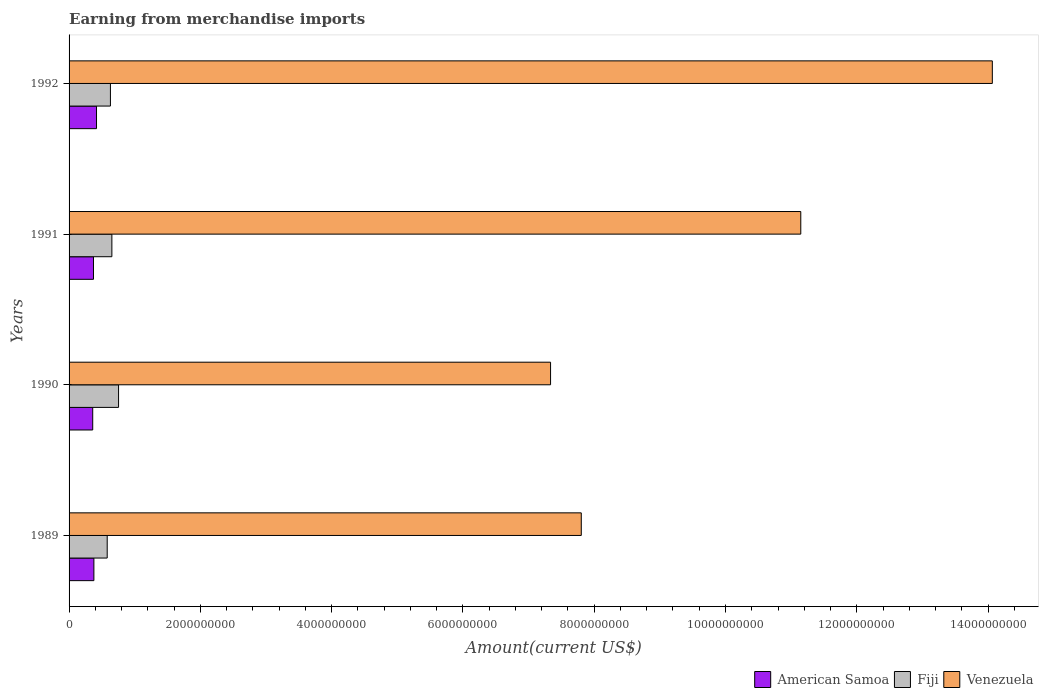How many groups of bars are there?
Make the answer very short. 4. Are the number of bars on each tick of the Y-axis equal?
Your response must be concise. Yes. How many bars are there on the 2nd tick from the top?
Ensure brevity in your answer.  3. How many bars are there on the 4th tick from the bottom?
Make the answer very short. 3. What is the amount earned from merchandise imports in Venezuela in 1992?
Provide a short and direct response. 1.41e+1. Across all years, what is the maximum amount earned from merchandise imports in Venezuela?
Your response must be concise. 1.41e+1. Across all years, what is the minimum amount earned from merchandise imports in Fiji?
Your response must be concise. 5.81e+08. In which year was the amount earned from merchandise imports in American Samoa minimum?
Give a very brief answer. 1990. What is the total amount earned from merchandise imports in Venezuela in the graph?
Offer a terse response. 4.04e+1. What is the difference between the amount earned from merchandise imports in American Samoa in 1991 and that in 1992?
Ensure brevity in your answer.  -4.61e+07. What is the difference between the amount earned from merchandise imports in Venezuela in 1990 and the amount earned from merchandise imports in American Samoa in 1991?
Make the answer very short. 6.96e+09. What is the average amount earned from merchandise imports in American Samoa per year?
Your response must be concise. 3.82e+08. In the year 1991, what is the difference between the amount earned from merchandise imports in Venezuela and amount earned from merchandise imports in American Samoa?
Keep it short and to the point. 1.08e+1. What is the ratio of the amount earned from merchandise imports in Fiji in 1990 to that in 1991?
Give a very brief answer. 1.16. Is the amount earned from merchandise imports in Venezuela in 1989 less than that in 1992?
Make the answer very short. Yes. Is the difference between the amount earned from merchandise imports in Venezuela in 1989 and 1991 greater than the difference between the amount earned from merchandise imports in American Samoa in 1989 and 1991?
Make the answer very short. No. What is the difference between the highest and the second highest amount earned from merchandise imports in Venezuela?
Provide a short and direct response. 2.92e+09. What is the difference between the highest and the lowest amount earned from merchandise imports in Venezuela?
Offer a terse response. 6.73e+09. Is the sum of the amount earned from merchandise imports in Venezuela in 1991 and 1992 greater than the maximum amount earned from merchandise imports in Fiji across all years?
Make the answer very short. Yes. What does the 2nd bar from the top in 1991 represents?
Offer a terse response. Fiji. What does the 1st bar from the bottom in 1990 represents?
Offer a very short reply. American Samoa. Is it the case that in every year, the sum of the amount earned from merchandise imports in Fiji and amount earned from merchandise imports in American Samoa is greater than the amount earned from merchandise imports in Venezuela?
Offer a terse response. No. Are all the bars in the graph horizontal?
Provide a succinct answer. Yes. What is the difference between two consecutive major ticks on the X-axis?
Your answer should be compact. 2.00e+09. Does the graph contain any zero values?
Make the answer very short. No. Does the graph contain grids?
Ensure brevity in your answer.  No. Where does the legend appear in the graph?
Provide a short and direct response. Bottom right. How many legend labels are there?
Provide a succinct answer. 3. How are the legend labels stacked?
Your response must be concise. Horizontal. What is the title of the graph?
Make the answer very short. Earning from merchandise imports. What is the label or title of the X-axis?
Your answer should be very brief. Amount(current US$). What is the Amount(current US$) of American Samoa in 1989?
Give a very brief answer. 3.78e+08. What is the Amount(current US$) of Fiji in 1989?
Keep it short and to the point. 5.81e+08. What is the Amount(current US$) of Venezuela in 1989?
Provide a short and direct response. 7.80e+09. What is the Amount(current US$) of American Samoa in 1990?
Give a very brief answer. 3.60e+08. What is the Amount(current US$) of Fiji in 1990?
Your answer should be very brief. 7.54e+08. What is the Amount(current US$) of Venezuela in 1990?
Offer a terse response. 7.34e+09. What is the Amount(current US$) of American Samoa in 1991?
Offer a very short reply. 3.72e+08. What is the Amount(current US$) of Fiji in 1991?
Your response must be concise. 6.52e+08. What is the Amount(current US$) in Venezuela in 1991?
Your answer should be compact. 1.11e+1. What is the Amount(current US$) in American Samoa in 1992?
Provide a succinct answer. 4.18e+08. What is the Amount(current US$) of Fiji in 1992?
Offer a terse response. 6.30e+08. What is the Amount(current US$) of Venezuela in 1992?
Make the answer very short. 1.41e+1. Across all years, what is the maximum Amount(current US$) in American Samoa?
Provide a short and direct response. 4.18e+08. Across all years, what is the maximum Amount(current US$) in Fiji?
Offer a terse response. 7.54e+08. Across all years, what is the maximum Amount(current US$) in Venezuela?
Keep it short and to the point. 1.41e+1. Across all years, what is the minimum Amount(current US$) in American Samoa?
Provide a succinct answer. 3.60e+08. Across all years, what is the minimum Amount(current US$) in Fiji?
Offer a very short reply. 5.81e+08. Across all years, what is the minimum Amount(current US$) in Venezuela?
Your response must be concise. 7.34e+09. What is the total Amount(current US$) of American Samoa in the graph?
Offer a very short reply. 1.53e+09. What is the total Amount(current US$) of Fiji in the graph?
Provide a succinct answer. 2.62e+09. What is the total Amount(current US$) of Venezuela in the graph?
Ensure brevity in your answer.  4.04e+1. What is the difference between the Amount(current US$) of American Samoa in 1989 and that in 1990?
Offer a very short reply. 1.77e+07. What is the difference between the Amount(current US$) of Fiji in 1989 and that in 1990?
Offer a terse response. -1.73e+08. What is the difference between the Amount(current US$) of Venezuela in 1989 and that in 1990?
Your answer should be compact. 4.68e+08. What is the difference between the Amount(current US$) in American Samoa in 1989 and that in 1991?
Provide a succinct answer. 6.10e+06. What is the difference between the Amount(current US$) of Fiji in 1989 and that in 1991?
Give a very brief answer. -7.10e+07. What is the difference between the Amount(current US$) in Venezuela in 1989 and that in 1991?
Your answer should be very brief. -3.34e+09. What is the difference between the Amount(current US$) of American Samoa in 1989 and that in 1992?
Your answer should be very brief. -4.00e+07. What is the difference between the Amount(current US$) of Fiji in 1989 and that in 1992?
Provide a succinct answer. -4.90e+07. What is the difference between the Amount(current US$) in Venezuela in 1989 and that in 1992?
Provide a succinct answer. -6.26e+09. What is the difference between the Amount(current US$) in American Samoa in 1990 and that in 1991?
Offer a very short reply. -1.16e+07. What is the difference between the Amount(current US$) of Fiji in 1990 and that in 1991?
Keep it short and to the point. 1.02e+08. What is the difference between the Amount(current US$) of Venezuela in 1990 and that in 1991?
Provide a short and direct response. -3.81e+09. What is the difference between the Amount(current US$) of American Samoa in 1990 and that in 1992?
Your answer should be very brief. -5.77e+07. What is the difference between the Amount(current US$) of Fiji in 1990 and that in 1992?
Ensure brevity in your answer.  1.24e+08. What is the difference between the Amount(current US$) of Venezuela in 1990 and that in 1992?
Your answer should be compact. -6.73e+09. What is the difference between the Amount(current US$) of American Samoa in 1991 and that in 1992?
Provide a short and direct response. -4.61e+07. What is the difference between the Amount(current US$) in Fiji in 1991 and that in 1992?
Your answer should be compact. 2.20e+07. What is the difference between the Amount(current US$) in Venezuela in 1991 and that in 1992?
Provide a short and direct response. -2.92e+09. What is the difference between the Amount(current US$) of American Samoa in 1989 and the Amount(current US$) of Fiji in 1990?
Offer a very short reply. -3.76e+08. What is the difference between the Amount(current US$) in American Samoa in 1989 and the Amount(current US$) in Venezuela in 1990?
Your response must be concise. -6.96e+09. What is the difference between the Amount(current US$) of Fiji in 1989 and the Amount(current US$) of Venezuela in 1990?
Provide a succinct answer. -6.75e+09. What is the difference between the Amount(current US$) of American Samoa in 1989 and the Amount(current US$) of Fiji in 1991?
Provide a short and direct response. -2.74e+08. What is the difference between the Amount(current US$) of American Samoa in 1989 and the Amount(current US$) of Venezuela in 1991?
Give a very brief answer. -1.08e+1. What is the difference between the Amount(current US$) in Fiji in 1989 and the Amount(current US$) in Venezuela in 1991?
Give a very brief answer. -1.06e+1. What is the difference between the Amount(current US$) in American Samoa in 1989 and the Amount(current US$) in Fiji in 1992?
Give a very brief answer. -2.52e+08. What is the difference between the Amount(current US$) in American Samoa in 1989 and the Amount(current US$) in Venezuela in 1992?
Make the answer very short. -1.37e+1. What is the difference between the Amount(current US$) in Fiji in 1989 and the Amount(current US$) in Venezuela in 1992?
Ensure brevity in your answer.  -1.35e+1. What is the difference between the Amount(current US$) in American Samoa in 1990 and the Amount(current US$) in Fiji in 1991?
Ensure brevity in your answer.  -2.92e+08. What is the difference between the Amount(current US$) in American Samoa in 1990 and the Amount(current US$) in Venezuela in 1991?
Your answer should be very brief. -1.08e+1. What is the difference between the Amount(current US$) of Fiji in 1990 and the Amount(current US$) of Venezuela in 1991?
Your answer should be very brief. -1.04e+1. What is the difference between the Amount(current US$) of American Samoa in 1990 and the Amount(current US$) of Fiji in 1992?
Your answer should be compact. -2.70e+08. What is the difference between the Amount(current US$) of American Samoa in 1990 and the Amount(current US$) of Venezuela in 1992?
Make the answer very short. -1.37e+1. What is the difference between the Amount(current US$) of Fiji in 1990 and the Amount(current US$) of Venezuela in 1992?
Your response must be concise. -1.33e+1. What is the difference between the Amount(current US$) in American Samoa in 1991 and the Amount(current US$) in Fiji in 1992?
Give a very brief answer. -2.58e+08. What is the difference between the Amount(current US$) in American Samoa in 1991 and the Amount(current US$) in Venezuela in 1992?
Provide a short and direct response. -1.37e+1. What is the difference between the Amount(current US$) in Fiji in 1991 and the Amount(current US$) in Venezuela in 1992?
Ensure brevity in your answer.  -1.34e+1. What is the average Amount(current US$) in American Samoa per year?
Offer a terse response. 3.82e+08. What is the average Amount(current US$) of Fiji per year?
Keep it short and to the point. 6.54e+08. What is the average Amount(current US$) in Venezuela per year?
Make the answer very short. 1.01e+1. In the year 1989, what is the difference between the Amount(current US$) of American Samoa and Amount(current US$) of Fiji?
Offer a very short reply. -2.03e+08. In the year 1989, what is the difference between the Amount(current US$) of American Samoa and Amount(current US$) of Venezuela?
Make the answer very short. -7.42e+09. In the year 1989, what is the difference between the Amount(current US$) of Fiji and Amount(current US$) of Venezuela?
Offer a very short reply. -7.22e+09. In the year 1990, what is the difference between the Amount(current US$) in American Samoa and Amount(current US$) in Fiji?
Keep it short and to the point. -3.94e+08. In the year 1990, what is the difference between the Amount(current US$) of American Samoa and Amount(current US$) of Venezuela?
Your answer should be compact. -6.97e+09. In the year 1990, what is the difference between the Amount(current US$) of Fiji and Amount(current US$) of Venezuela?
Your answer should be compact. -6.58e+09. In the year 1991, what is the difference between the Amount(current US$) of American Samoa and Amount(current US$) of Fiji?
Give a very brief answer. -2.80e+08. In the year 1991, what is the difference between the Amount(current US$) of American Samoa and Amount(current US$) of Venezuela?
Keep it short and to the point. -1.08e+1. In the year 1991, what is the difference between the Amount(current US$) in Fiji and Amount(current US$) in Venezuela?
Offer a very short reply. -1.05e+1. In the year 1992, what is the difference between the Amount(current US$) in American Samoa and Amount(current US$) in Fiji?
Provide a short and direct response. -2.12e+08. In the year 1992, what is the difference between the Amount(current US$) in American Samoa and Amount(current US$) in Venezuela?
Your answer should be compact. -1.36e+1. In the year 1992, what is the difference between the Amount(current US$) of Fiji and Amount(current US$) of Venezuela?
Provide a short and direct response. -1.34e+1. What is the ratio of the Amount(current US$) of American Samoa in 1989 to that in 1990?
Offer a terse response. 1.05. What is the ratio of the Amount(current US$) in Fiji in 1989 to that in 1990?
Your answer should be very brief. 0.77. What is the ratio of the Amount(current US$) of Venezuela in 1989 to that in 1990?
Provide a short and direct response. 1.06. What is the ratio of the Amount(current US$) in American Samoa in 1989 to that in 1991?
Your answer should be very brief. 1.02. What is the ratio of the Amount(current US$) in Fiji in 1989 to that in 1991?
Ensure brevity in your answer.  0.89. What is the ratio of the Amount(current US$) in American Samoa in 1989 to that in 1992?
Offer a terse response. 0.9. What is the ratio of the Amount(current US$) of Fiji in 1989 to that in 1992?
Offer a terse response. 0.92. What is the ratio of the Amount(current US$) in Venezuela in 1989 to that in 1992?
Your answer should be compact. 0.55. What is the ratio of the Amount(current US$) in American Samoa in 1990 to that in 1991?
Keep it short and to the point. 0.97. What is the ratio of the Amount(current US$) of Fiji in 1990 to that in 1991?
Your response must be concise. 1.16. What is the ratio of the Amount(current US$) of Venezuela in 1990 to that in 1991?
Offer a very short reply. 0.66. What is the ratio of the Amount(current US$) of American Samoa in 1990 to that in 1992?
Ensure brevity in your answer.  0.86. What is the ratio of the Amount(current US$) of Fiji in 1990 to that in 1992?
Keep it short and to the point. 1.2. What is the ratio of the Amount(current US$) in Venezuela in 1990 to that in 1992?
Provide a succinct answer. 0.52. What is the ratio of the Amount(current US$) of American Samoa in 1991 to that in 1992?
Your answer should be compact. 0.89. What is the ratio of the Amount(current US$) in Fiji in 1991 to that in 1992?
Provide a succinct answer. 1.03. What is the ratio of the Amount(current US$) of Venezuela in 1991 to that in 1992?
Offer a terse response. 0.79. What is the difference between the highest and the second highest Amount(current US$) in American Samoa?
Provide a succinct answer. 4.00e+07. What is the difference between the highest and the second highest Amount(current US$) in Fiji?
Ensure brevity in your answer.  1.02e+08. What is the difference between the highest and the second highest Amount(current US$) of Venezuela?
Ensure brevity in your answer.  2.92e+09. What is the difference between the highest and the lowest Amount(current US$) of American Samoa?
Keep it short and to the point. 5.77e+07. What is the difference between the highest and the lowest Amount(current US$) in Fiji?
Offer a very short reply. 1.73e+08. What is the difference between the highest and the lowest Amount(current US$) in Venezuela?
Your answer should be compact. 6.73e+09. 